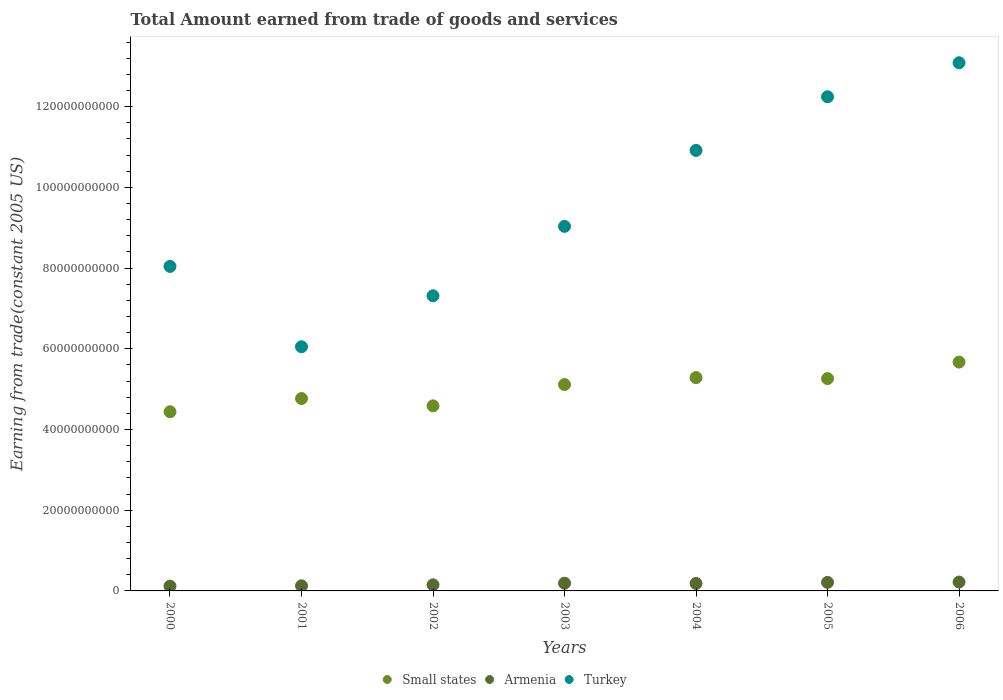Is the number of dotlines equal to the number of legend labels?
Make the answer very short. Yes. What is the total amount earned by trading goods and services in Small states in 2003?
Your answer should be very brief. 5.11e+1. Across all years, what is the maximum total amount earned by trading goods and services in Turkey?
Make the answer very short. 1.31e+11. Across all years, what is the minimum total amount earned by trading goods and services in Turkey?
Your response must be concise. 6.05e+1. In which year was the total amount earned by trading goods and services in Small states maximum?
Provide a short and direct response. 2006. What is the total total amount earned by trading goods and services in Turkey in the graph?
Ensure brevity in your answer.  6.67e+11. What is the difference between the total amount earned by trading goods and services in Armenia in 2001 and that in 2003?
Provide a succinct answer. -6.41e+08. What is the difference between the total amount earned by trading goods and services in Small states in 2006 and the total amount earned by trading goods and services in Armenia in 2002?
Your response must be concise. 5.52e+1. What is the average total amount earned by trading goods and services in Turkey per year?
Your answer should be compact. 9.53e+1. In the year 2003, what is the difference between the total amount earned by trading goods and services in Turkey and total amount earned by trading goods and services in Armenia?
Your answer should be compact. 8.84e+1. What is the ratio of the total amount earned by trading goods and services in Turkey in 2002 to that in 2005?
Give a very brief answer. 0.6. Is the total amount earned by trading goods and services in Turkey in 2003 less than that in 2006?
Your answer should be very brief. Yes. Is the difference between the total amount earned by trading goods and services in Turkey in 2002 and 2004 greater than the difference between the total amount earned by trading goods and services in Armenia in 2002 and 2004?
Ensure brevity in your answer.  No. What is the difference between the highest and the second highest total amount earned by trading goods and services in Turkey?
Provide a short and direct response. 8.43e+09. What is the difference between the highest and the lowest total amount earned by trading goods and services in Turkey?
Provide a short and direct response. 7.04e+1. In how many years, is the total amount earned by trading goods and services in Small states greater than the average total amount earned by trading goods and services in Small states taken over all years?
Provide a short and direct response. 4. Is the sum of the total amount earned by trading goods and services in Turkey in 2000 and 2003 greater than the maximum total amount earned by trading goods and services in Armenia across all years?
Offer a very short reply. Yes. Is it the case that in every year, the sum of the total amount earned by trading goods and services in Small states and total amount earned by trading goods and services in Armenia  is greater than the total amount earned by trading goods and services in Turkey?
Offer a very short reply. No. How many years are there in the graph?
Provide a short and direct response. 7. What is the difference between two consecutive major ticks on the Y-axis?
Give a very brief answer. 2.00e+1. Are the values on the major ticks of Y-axis written in scientific E-notation?
Provide a short and direct response. No. Where does the legend appear in the graph?
Give a very brief answer. Bottom center. How are the legend labels stacked?
Offer a very short reply. Horizontal. What is the title of the graph?
Offer a terse response. Total Amount earned from trade of goods and services. Does "Guam" appear as one of the legend labels in the graph?
Provide a succinct answer. No. What is the label or title of the X-axis?
Give a very brief answer. Years. What is the label or title of the Y-axis?
Keep it short and to the point. Earning from trade(constant 2005 US). What is the Earning from trade(constant 2005 US) in Small states in 2000?
Make the answer very short. 4.44e+1. What is the Earning from trade(constant 2005 US) of Armenia in 2000?
Provide a succinct answer. 1.19e+09. What is the Earning from trade(constant 2005 US) of Turkey in 2000?
Offer a terse response. 8.04e+1. What is the Earning from trade(constant 2005 US) in Small states in 2001?
Your answer should be very brief. 4.77e+1. What is the Earning from trade(constant 2005 US) in Armenia in 2001?
Give a very brief answer. 1.27e+09. What is the Earning from trade(constant 2005 US) of Turkey in 2001?
Provide a short and direct response. 6.05e+1. What is the Earning from trade(constant 2005 US) in Small states in 2002?
Offer a terse response. 4.59e+1. What is the Earning from trade(constant 2005 US) of Armenia in 2002?
Keep it short and to the point. 1.51e+09. What is the Earning from trade(constant 2005 US) of Turkey in 2002?
Your answer should be very brief. 7.31e+1. What is the Earning from trade(constant 2005 US) of Small states in 2003?
Your response must be concise. 5.11e+1. What is the Earning from trade(constant 2005 US) of Armenia in 2003?
Keep it short and to the point. 1.91e+09. What is the Earning from trade(constant 2005 US) of Turkey in 2003?
Your response must be concise. 9.03e+1. What is the Earning from trade(constant 2005 US) in Small states in 2004?
Provide a short and direct response. 5.29e+1. What is the Earning from trade(constant 2005 US) in Armenia in 2004?
Keep it short and to the point. 1.85e+09. What is the Earning from trade(constant 2005 US) in Turkey in 2004?
Offer a terse response. 1.09e+11. What is the Earning from trade(constant 2005 US) of Small states in 2005?
Provide a succinct answer. 5.26e+1. What is the Earning from trade(constant 2005 US) of Armenia in 2005?
Provide a succinct answer. 2.12e+09. What is the Earning from trade(constant 2005 US) in Turkey in 2005?
Provide a short and direct response. 1.22e+11. What is the Earning from trade(constant 2005 US) in Small states in 2006?
Your answer should be very brief. 5.67e+1. What is the Earning from trade(constant 2005 US) of Armenia in 2006?
Make the answer very short. 2.20e+09. What is the Earning from trade(constant 2005 US) in Turkey in 2006?
Make the answer very short. 1.31e+11. Across all years, what is the maximum Earning from trade(constant 2005 US) in Small states?
Your answer should be very brief. 5.67e+1. Across all years, what is the maximum Earning from trade(constant 2005 US) of Armenia?
Keep it short and to the point. 2.20e+09. Across all years, what is the maximum Earning from trade(constant 2005 US) of Turkey?
Your answer should be very brief. 1.31e+11. Across all years, what is the minimum Earning from trade(constant 2005 US) of Small states?
Provide a short and direct response. 4.44e+1. Across all years, what is the minimum Earning from trade(constant 2005 US) in Armenia?
Your response must be concise. 1.19e+09. Across all years, what is the minimum Earning from trade(constant 2005 US) in Turkey?
Your answer should be compact. 6.05e+1. What is the total Earning from trade(constant 2005 US) in Small states in the graph?
Offer a terse response. 3.51e+11. What is the total Earning from trade(constant 2005 US) in Armenia in the graph?
Keep it short and to the point. 1.20e+1. What is the total Earning from trade(constant 2005 US) in Turkey in the graph?
Your answer should be compact. 6.67e+11. What is the difference between the Earning from trade(constant 2005 US) of Small states in 2000 and that in 2001?
Offer a very short reply. -3.28e+09. What is the difference between the Earning from trade(constant 2005 US) of Armenia in 2000 and that in 2001?
Give a very brief answer. -7.64e+07. What is the difference between the Earning from trade(constant 2005 US) in Turkey in 2000 and that in 2001?
Keep it short and to the point. 1.99e+1. What is the difference between the Earning from trade(constant 2005 US) in Small states in 2000 and that in 2002?
Ensure brevity in your answer.  -1.47e+09. What is the difference between the Earning from trade(constant 2005 US) in Armenia in 2000 and that in 2002?
Offer a terse response. -3.17e+08. What is the difference between the Earning from trade(constant 2005 US) in Turkey in 2000 and that in 2002?
Offer a very short reply. 7.28e+09. What is the difference between the Earning from trade(constant 2005 US) in Small states in 2000 and that in 2003?
Make the answer very short. -6.75e+09. What is the difference between the Earning from trade(constant 2005 US) in Armenia in 2000 and that in 2003?
Your answer should be compact. -7.17e+08. What is the difference between the Earning from trade(constant 2005 US) of Turkey in 2000 and that in 2003?
Your response must be concise. -9.92e+09. What is the difference between the Earning from trade(constant 2005 US) in Small states in 2000 and that in 2004?
Keep it short and to the point. -8.46e+09. What is the difference between the Earning from trade(constant 2005 US) in Armenia in 2000 and that in 2004?
Provide a succinct answer. -6.61e+08. What is the difference between the Earning from trade(constant 2005 US) in Turkey in 2000 and that in 2004?
Make the answer very short. -2.87e+1. What is the difference between the Earning from trade(constant 2005 US) in Small states in 2000 and that in 2005?
Ensure brevity in your answer.  -8.22e+09. What is the difference between the Earning from trade(constant 2005 US) in Armenia in 2000 and that in 2005?
Your answer should be compact. -9.26e+08. What is the difference between the Earning from trade(constant 2005 US) of Turkey in 2000 and that in 2005?
Your response must be concise. -4.20e+1. What is the difference between the Earning from trade(constant 2005 US) in Small states in 2000 and that in 2006?
Keep it short and to the point. -1.23e+1. What is the difference between the Earning from trade(constant 2005 US) of Armenia in 2000 and that in 2006?
Offer a terse response. -1.01e+09. What is the difference between the Earning from trade(constant 2005 US) in Turkey in 2000 and that in 2006?
Your answer should be very brief. -5.05e+1. What is the difference between the Earning from trade(constant 2005 US) of Small states in 2001 and that in 2002?
Provide a succinct answer. 1.81e+09. What is the difference between the Earning from trade(constant 2005 US) in Armenia in 2001 and that in 2002?
Offer a very short reply. -2.40e+08. What is the difference between the Earning from trade(constant 2005 US) of Turkey in 2001 and that in 2002?
Keep it short and to the point. -1.26e+1. What is the difference between the Earning from trade(constant 2005 US) of Small states in 2001 and that in 2003?
Your response must be concise. -3.47e+09. What is the difference between the Earning from trade(constant 2005 US) of Armenia in 2001 and that in 2003?
Keep it short and to the point. -6.41e+08. What is the difference between the Earning from trade(constant 2005 US) of Turkey in 2001 and that in 2003?
Provide a short and direct response. -2.98e+1. What is the difference between the Earning from trade(constant 2005 US) of Small states in 2001 and that in 2004?
Make the answer very short. -5.18e+09. What is the difference between the Earning from trade(constant 2005 US) of Armenia in 2001 and that in 2004?
Give a very brief answer. -5.85e+08. What is the difference between the Earning from trade(constant 2005 US) of Turkey in 2001 and that in 2004?
Give a very brief answer. -4.87e+1. What is the difference between the Earning from trade(constant 2005 US) of Small states in 2001 and that in 2005?
Your answer should be compact. -4.94e+09. What is the difference between the Earning from trade(constant 2005 US) in Armenia in 2001 and that in 2005?
Your response must be concise. -8.50e+08. What is the difference between the Earning from trade(constant 2005 US) in Turkey in 2001 and that in 2005?
Offer a very short reply. -6.19e+1. What is the difference between the Earning from trade(constant 2005 US) in Small states in 2001 and that in 2006?
Ensure brevity in your answer.  -9.03e+09. What is the difference between the Earning from trade(constant 2005 US) of Armenia in 2001 and that in 2006?
Provide a short and direct response. -9.30e+08. What is the difference between the Earning from trade(constant 2005 US) in Turkey in 2001 and that in 2006?
Offer a very short reply. -7.04e+1. What is the difference between the Earning from trade(constant 2005 US) in Small states in 2002 and that in 2003?
Your response must be concise. -5.28e+09. What is the difference between the Earning from trade(constant 2005 US) of Armenia in 2002 and that in 2003?
Offer a terse response. -4.00e+08. What is the difference between the Earning from trade(constant 2005 US) in Turkey in 2002 and that in 2003?
Offer a very short reply. -1.72e+1. What is the difference between the Earning from trade(constant 2005 US) in Small states in 2002 and that in 2004?
Make the answer very short. -7.00e+09. What is the difference between the Earning from trade(constant 2005 US) in Armenia in 2002 and that in 2004?
Provide a succinct answer. -3.45e+08. What is the difference between the Earning from trade(constant 2005 US) of Turkey in 2002 and that in 2004?
Ensure brevity in your answer.  -3.60e+1. What is the difference between the Earning from trade(constant 2005 US) of Small states in 2002 and that in 2005?
Your response must be concise. -6.75e+09. What is the difference between the Earning from trade(constant 2005 US) of Armenia in 2002 and that in 2005?
Make the answer very short. -6.10e+08. What is the difference between the Earning from trade(constant 2005 US) of Turkey in 2002 and that in 2005?
Keep it short and to the point. -4.93e+1. What is the difference between the Earning from trade(constant 2005 US) in Small states in 2002 and that in 2006?
Ensure brevity in your answer.  -1.08e+1. What is the difference between the Earning from trade(constant 2005 US) in Armenia in 2002 and that in 2006?
Your answer should be very brief. -6.89e+08. What is the difference between the Earning from trade(constant 2005 US) in Turkey in 2002 and that in 2006?
Your response must be concise. -5.77e+1. What is the difference between the Earning from trade(constant 2005 US) in Small states in 2003 and that in 2004?
Provide a succinct answer. -1.72e+09. What is the difference between the Earning from trade(constant 2005 US) in Armenia in 2003 and that in 2004?
Your answer should be very brief. 5.58e+07. What is the difference between the Earning from trade(constant 2005 US) in Turkey in 2003 and that in 2004?
Your answer should be compact. -1.88e+1. What is the difference between the Earning from trade(constant 2005 US) in Small states in 2003 and that in 2005?
Provide a short and direct response. -1.47e+09. What is the difference between the Earning from trade(constant 2005 US) of Armenia in 2003 and that in 2005?
Your answer should be compact. -2.09e+08. What is the difference between the Earning from trade(constant 2005 US) of Turkey in 2003 and that in 2005?
Your answer should be very brief. -3.21e+1. What is the difference between the Earning from trade(constant 2005 US) of Small states in 2003 and that in 2006?
Ensure brevity in your answer.  -5.57e+09. What is the difference between the Earning from trade(constant 2005 US) in Armenia in 2003 and that in 2006?
Your answer should be very brief. -2.89e+08. What is the difference between the Earning from trade(constant 2005 US) of Turkey in 2003 and that in 2006?
Keep it short and to the point. -4.05e+1. What is the difference between the Earning from trade(constant 2005 US) of Small states in 2004 and that in 2005?
Offer a terse response. 2.44e+08. What is the difference between the Earning from trade(constant 2005 US) of Armenia in 2004 and that in 2005?
Keep it short and to the point. -2.65e+08. What is the difference between the Earning from trade(constant 2005 US) in Turkey in 2004 and that in 2005?
Provide a short and direct response. -1.33e+1. What is the difference between the Earning from trade(constant 2005 US) of Small states in 2004 and that in 2006?
Give a very brief answer. -3.85e+09. What is the difference between the Earning from trade(constant 2005 US) of Armenia in 2004 and that in 2006?
Your response must be concise. -3.45e+08. What is the difference between the Earning from trade(constant 2005 US) of Turkey in 2004 and that in 2006?
Give a very brief answer. -2.17e+1. What is the difference between the Earning from trade(constant 2005 US) in Small states in 2005 and that in 2006?
Give a very brief answer. -4.09e+09. What is the difference between the Earning from trade(constant 2005 US) in Armenia in 2005 and that in 2006?
Your answer should be compact. -7.97e+07. What is the difference between the Earning from trade(constant 2005 US) in Turkey in 2005 and that in 2006?
Ensure brevity in your answer.  -8.43e+09. What is the difference between the Earning from trade(constant 2005 US) of Small states in 2000 and the Earning from trade(constant 2005 US) of Armenia in 2001?
Ensure brevity in your answer.  4.31e+1. What is the difference between the Earning from trade(constant 2005 US) of Small states in 2000 and the Earning from trade(constant 2005 US) of Turkey in 2001?
Ensure brevity in your answer.  -1.61e+1. What is the difference between the Earning from trade(constant 2005 US) of Armenia in 2000 and the Earning from trade(constant 2005 US) of Turkey in 2001?
Offer a terse response. -5.93e+1. What is the difference between the Earning from trade(constant 2005 US) in Small states in 2000 and the Earning from trade(constant 2005 US) in Armenia in 2002?
Keep it short and to the point. 4.29e+1. What is the difference between the Earning from trade(constant 2005 US) in Small states in 2000 and the Earning from trade(constant 2005 US) in Turkey in 2002?
Your answer should be very brief. -2.87e+1. What is the difference between the Earning from trade(constant 2005 US) of Armenia in 2000 and the Earning from trade(constant 2005 US) of Turkey in 2002?
Keep it short and to the point. -7.19e+1. What is the difference between the Earning from trade(constant 2005 US) of Small states in 2000 and the Earning from trade(constant 2005 US) of Armenia in 2003?
Offer a very short reply. 4.25e+1. What is the difference between the Earning from trade(constant 2005 US) of Small states in 2000 and the Earning from trade(constant 2005 US) of Turkey in 2003?
Keep it short and to the point. -4.59e+1. What is the difference between the Earning from trade(constant 2005 US) in Armenia in 2000 and the Earning from trade(constant 2005 US) in Turkey in 2003?
Provide a short and direct response. -8.91e+1. What is the difference between the Earning from trade(constant 2005 US) in Small states in 2000 and the Earning from trade(constant 2005 US) in Armenia in 2004?
Your answer should be very brief. 4.25e+1. What is the difference between the Earning from trade(constant 2005 US) in Small states in 2000 and the Earning from trade(constant 2005 US) in Turkey in 2004?
Offer a very short reply. -6.48e+1. What is the difference between the Earning from trade(constant 2005 US) in Armenia in 2000 and the Earning from trade(constant 2005 US) in Turkey in 2004?
Ensure brevity in your answer.  -1.08e+11. What is the difference between the Earning from trade(constant 2005 US) of Small states in 2000 and the Earning from trade(constant 2005 US) of Armenia in 2005?
Provide a succinct answer. 4.23e+1. What is the difference between the Earning from trade(constant 2005 US) of Small states in 2000 and the Earning from trade(constant 2005 US) of Turkey in 2005?
Make the answer very short. -7.81e+1. What is the difference between the Earning from trade(constant 2005 US) in Armenia in 2000 and the Earning from trade(constant 2005 US) in Turkey in 2005?
Your answer should be compact. -1.21e+11. What is the difference between the Earning from trade(constant 2005 US) in Small states in 2000 and the Earning from trade(constant 2005 US) in Armenia in 2006?
Keep it short and to the point. 4.22e+1. What is the difference between the Earning from trade(constant 2005 US) in Small states in 2000 and the Earning from trade(constant 2005 US) in Turkey in 2006?
Provide a succinct answer. -8.65e+1. What is the difference between the Earning from trade(constant 2005 US) of Armenia in 2000 and the Earning from trade(constant 2005 US) of Turkey in 2006?
Offer a terse response. -1.30e+11. What is the difference between the Earning from trade(constant 2005 US) of Small states in 2001 and the Earning from trade(constant 2005 US) of Armenia in 2002?
Your response must be concise. 4.62e+1. What is the difference between the Earning from trade(constant 2005 US) of Small states in 2001 and the Earning from trade(constant 2005 US) of Turkey in 2002?
Offer a terse response. -2.55e+1. What is the difference between the Earning from trade(constant 2005 US) in Armenia in 2001 and the Earning from trade(constant 2005 US) in Turkey in 2002?
Your answer should be very brief. -7.19e+1. What is the difference between the Earning from trade(constant 2005 US) in Small states in 2001 and the Earning from trade(constant 2005 US) in Armenia in 2003?
Provide a short and direct response. 4.58e+1. What is the difference between the Earning from trade(constant 2005 US) of Small states in 2001 and the Earning from trade(constant 2005 US) of Turkey in 2003?
Keep it short and to the point. -4.27e+1. What is the difference between the Earning from trade(constant 2005 US) in Armenia in 2001 and the Earning from trade(constant 2005 US) in Turkey in 2003?
Offer a terse response. -8.91e+1. What is the difference between the Earning from trade(constant 2005 US) in Small states in 2001 and the Earning from trade(constant 2005 US) in Armenia in 2004?
Your answer should be compact. 4.58e+1. What is the difference between the Earning from trade(constant 2005 US) of Small states in 2001 and the Earning from trade(constant 2005 US) of Turkey in 2004?
Offer a terse response. -6.15e+1. What is the difference between the Earning from trade(constant 2005 US) in Armenia in 2001 and the Earning from trade(constant 2005 US) in Turkey in 2004?
Your response must be concise. -1.08e+11. What is the difference between the Earning from trade(constant 2005 US) of Small states in 2001 and the Earning from trade(constant 2005 US) of Armenia in 2005?
Your response must be concise. 4.56e+1. What is the difference between the Earning from trade(constant 2005 US) of Small states in 2001 and the Earning from trade(constant 2005 US) of Turkey in 2005?
Your response must be concise. -7.48e+1. What is the difference between the Earning from trade(constant 2005 US) in Armenia in 2001 and the Earning from trade(constant 2005 US) in Turkey in 2005?
Offer a very short reply. -1.21e+11. What is the difference between the Earning from trade(constant 2005 US) in Small states in 2001 and the Earning from trade(constant 2005 US) in Armenia in 2006?
Provide a short and direct response. 4.55e+1. What is the difference between the Earning from trade(constant 2005 US) in Small states in 2001 and the Earning from trade(constant 2005 US) in Turkey in 2006?
Ensure brevity in your answer.  -8.32e+1. What is the difference between the Earning from trade(constant 2005 US) in Armenia in 2001 and the Earning from trade(constant 2005 US) in Turkey in 2006?
Give a very brief answer. -1.30e+11. What is the difference between the Earning from trade(constant 2005 US) of Small states in 2002 and the Earning from trade(constant 2005 US) of Armenia in 2003?
Offer a very short reply. 4.39e+1. What is the difference between the Earning from trade(constant 2005 US) of Small states in 2002 and the Earning from trade(constant 2005 US) of Turkey in 2003?
Offer a terse response. -4.45e+1. What is the difference between the Earning from trade(constant 2005 US) of Armenia in 2002 and the Earning from trade(constant 2005 US) of Turkey in 2003?
Give a very brief answer. -8.88e+1. What is the difference between the Earning from trade(constant 2005 US) of Small states in 2002 and the Earning from trade(constant 2005 US) of Armenia in 2004?
Ensure brevity in your answer.  4.40e+1. What is the difference between the Earning from trade(constant 2005 US) in Small states in 2002 and the Earning from trade(constant 2005 US) in Turkey in 2004?
Keep it short and to the point. -6.33e+1. What is the difference between the Earning from trade(constant 2005 US) in Armenia in 2002 and the Earning from trade(constant 2005 US) in Turkey in 2004?
Your response must be concise. -1.08e+11. What is the difference between the Earning from trade(constant 2005 US) of Small states in 2002 and the Earning from trade(constant 2005 US) of Armenia in 2005?
Give a very brief answer. 4.37e+1. What is the difference between the Earning from trade(constant 2005 US) in Small states in 2002 and the Earning from trade(constant 2005 US) in Turkey in 2005?
Make the answer very short. -7.66e+1. What is the difference between the Earning from trade(constant 2005 US) of Armenia in 2002 and the Earning from trade(constant 2005 US) of Turkey in 2005?
Give a very brief answer. -1.21e+11. What is the difference between the Earning from trade(constant 2005 US) in Small states in 2002 and the Earning from trade(constant 2005 US) in Armenia in 2006?
Give a very brief answer. 4.37e+1. What is the difference between the Earning from trade(constant 2005 US) in Small states in 2002 and the Earning from trade(constant 2005 US) in Turkey in 2006?
Make the answer very short. -8.50e+1. What is the difference between the Earning from trade(constant 2005 US) of Armenia in 2002 and the Earning from trade(constant 2005 US) of Turkey in 2006?
Keep it short and to the point. -1.29e+11. What is the difference between the Earning from trade(constant 2005 US) in Small states in 2003 and the Earning from trade(constant 2005 US) in Armenia in 2004?
Your answer should be compact. 4.93e+1. What is the difference between the Earning from trade(constant 2005 US) of Small states in 2003 and the Earning from trade(constant 2005 US) of Turkey in 2004?
Provide a short and direct response. -5.80e+1. What is the difference between the Earning from trade(constant 2005 US) in Armenia in 2003 and the Earning from trade(constant 2005 US) in Turkey in 2004?
Your response must be concise. -1.07e+11. What is the difference between the Earning from trade(constant 2005 US) of Small states in 2003 and the Earning from trade(constant 2005 US) of Armenia in 2005?
Make the answer very short. 4.90e+1. What is the difference between the Earning from trade(constant 2005 US) of Small states in 2003 and the Earning from trade(constant 2005 US) of Turkey in 2005?
Your answer should be compact. -7.13e+1. What is the difference between the Earning from trade(constant 2005 US) in Armenia in 2003 and the Earning from trade(constant 2005 US) in Turkey in 2005?
Ensure brevity in your answer.  -1.21e+11. What is the difference between the Earning from trade(constant 2005 US) in Small states in 2003 and the Earning from trade(constant 2005 US) in Armenia in 2006?
Make the answer very short. 4.89e+1. What is the difference between the Earning from trade(constant 2005 US) in Small states in 2003 and the Earning from trade(constant 2005 US) in Turkey in 2006?
Your answer should be compact. -7.97e+1. What is the difference between the Earning from trade(constant 2005 US) of Armenia in 2003 and the Earning from trade(constant 2005 US) of Turkey in 2006?
Give a very brief answer. -1.29e+11. What is the difference between the Earning from trade(constant 2005 US) of Small states in 2004 and the Earning from trade(constant 2005 US) of Armenia in 2005?
Offer a terse response. 5.07e+1. What is the difference between the Earning from trade(constant 2005 US) in Small states in 2004 and the Earning from trade(constant 2005 US) in Turkey in 2005?
Your answer should be very brief. -6.96e+1. What is the difference between the Earning from trade(constant 2005 US) of Armenia in 2004 and the Earning from trade(constant 2005 US) of Turkey in 2005?
Ensure brevity in your answer.  -1.21e+11. What is the difference between the Earning from trade(constant 2005 US) of Small states in 2004 and the Earning from trade(constant 2005 US) of Armenia in 2006?
Provide a succinct answer. 5.07e+1. What is the difference between the Earning from trade(constant 2005 US) in Small states in 2004 and the Earning from trade(constant 2005 US) in Turkey in 2006?
Provide a short and direct response. -7.80e+1. What is the difference between the Earning from trade(constant 2005 US) in Armenia in 2004 and the Earning from trade(constant 2005 US) in Turkey in 2006?
Offer a terse response. -1.29e+11. What is the difference between the Earning from trade(constant 2005 US) of Small states in 2005 and the Earning from trade(constant 2005 US) of Armenia in 2006?
Provide a short and direct response. 5.04e+1. What is the difference between the Earning from trade(constant 2005 US) in Small states in 2005 and the Earning from trade(constant 2005 US) in Turkey in 2006?
Give a very brief answer. -7.83e+1. What is the difference between the Earning from trade(constant 2005 US) in Armenia in 2005 and the Earning from trade(constant 2005 US) in Turkey in 2006?
Give a very brief answer. -1.29e+11. What is the average Earning from trade(constant 2005 US) of Small states per year?
Your answer should be very brief. 5.02e+1. What is the average Earning from trade(constant 2005 US) in Armenia per year?
Offer a very short reply. 1.72e+09. What is the average Earning from trade(constant 2005 US) in Turkey per year?
Offer a terse response. 9.53e+1. In the year 2000, what is the difference between the Earning from trade(constant 2005 US) in Small states and Earning from trade(constant 2005 US) in Armenia?
Your answer should be compact. 4.32e+1. In the year 2000, what is the difference between the Earning from trade(constant 2005 US) of Small states and Earning from trade(constant 2005 US) of Turkey?
Keep it short and to the point. -3.60e+1. In the year 2000, what is the difference between the Earning from trade(constant 2005 US) of Armenia and Earning from trade(constant 2005 US) of Turkey?
Make the answer very short. -7.92e+1. In the year 2001, what is the difference between the Earning from trade(constant 2005 US) in Small states and Earning from trade(constant 2005 US) in Armenia?
Keep it short and to the point. 4.64e+1. In the year 2001, what is the difference between the Earning from trade(constant 2005 US) of Small states and Earning from trade(constant 2005 US) of Turkey?
Provide a short and direct response. -1.28e+1. In the year 2001, what is the difference between the Earning from trade(constant 2005 US) of Armenia and Earning from trade(constant 2005 US) of Turkey?
Offer a terse response. -5.92e+1. In the year 2002, what is the difference between the Earning from trade(constant 2005 US) of Small states and Earning from trade(constant 2005 US) of Armenia?
Provide a short and direct response. 4.43e+1. In the year 2002, what is the difference between the Earning from trade(constant 2005 US) in Small states and Earning from trade(constant 2005 US) in Turkey?
Provide a short and direct response. -2.73e+1. In the year 2002, what is the difference between the Earning from trade(constant 2005 US) of Armenia and Earning from trade(constant 2005 US) of Turkey?
Your response must be concise. -7.16e+1. In the year 2003, what is the difference between the Earning from trade(constant 2005 US) in Small states and Earning from trade(constant 2005 US) in Armenia?
Keep it short and to the point. 4.92e+1. In the year 2003, what is the difference between the Earning from trade(constant 2005 US) in Small states and Earning from trade(constant 2005 US) in Turkey?
Provide a short and direct response. -3.92e+1. In the year 2003, what is the difference between the Earning from trade(constant 2005 US) in Armenia and Earning from trade(constant 2005 US) in Turkey?
Your answer should be very brief. -8.84e+1. In the year 2004, what is the difference between the Earning from trade(constant 2005 US) of Small states and Earning from trade(constant 2005 US) of Armenia?
Ensure brevity in your answer.  5.10e+1. In the year 2004, what is the difference between the Earning from trade(constant 2005 US) in Small states and Earning from trade(constant 2005 US) in Turkey?
Ensure brevity in your answer.  -5.63e+1. In the year 2004, what is the difference between the Earning from trade(constant 2005 US) in Armenia and Earning from trade(constant 2005 US) in Turkey?
Give a very brief answer. -1.07e+11. In the year 2005, what is the difference between the Earning from trade(constant 2005 US) in Small states and Earning from trade(constant 2005 US) in Armenia?
Your answer should be very brief. 5.05e+1. In the year 2005, what is the difference between the Earning from trade(constant 2005 US) of Small states and Earning from trade(constant 2005 US) of Turkey?
Your answer should be very brief. -6.98e+1. In the year 2005, what is the difference between the Earning from trade(constant 2005 US) in Armenia and Earning from trade(constant 2005 US) in Turkey?
Keep it short and to the point. -1.20e+11. In the year 2006, what is the difference between the Earning from trade(constant 2005 US) of Small states and Earning from trade(constant 2005 US) of Armenia?
Provide a succinct answer. 5.45e+1. In the year 2006, what is the difference between the Earning from trade(constant 2005 US) in Small states and Earning from trade(constant 2005 US) in Turkey?
Ensure brevity in your answer.  -7.42e+1. In the year 2006, what is the difference between the Earning from trade(constant 2005 US) in Armenia and Earning from trade(constant 2005 US) in Turkey?
Make the answer very short. -1.29e+11. What is the ratio of the Earning from trade(constant 2005 US) of Small states in 2000 to that in 2001?
Give a very brief answer. 0.93. What is the ratio of the Earning from trade(constant 2005 US) of Armenia in 2000 to that in 2001?
Your answer should be compact. 0.94. What is the ratio of the Earning from trade(constant 2005 US) in Turkey in 2000 to that in 2001?
Provide a succinct answer. 1.33. What is the ratio of the Earning from trade(constant 2005 US) of Armenia in 2000 to that in 2002?
Give a very brief answer. 0.79. What is the ratio of the Earning from trade(constant 2005 US) in Turkey in 2000 to that in 2002?
Offer a terse response. 1.1. What is the ratio of the Earning from trade(constant 2005 US) in Small states in 2000 to that in 2003?
Ensure brevity in your answer.  0.87. What is the ratio of the Earning from trade(constant 2005 US) of Armenia in 2000 to that in 2003?
Offer a very short reply. 0.62. What is the ratio of the Earning from trade(constant 2005 US) of Turkey in 2000 to that in 2003?
Offer a very short reply. 0.89. What is the ratio of the Earning from trade(constant 2005 US) in Small states in 2000 to that in 2004?
Your response must be concise. 0.84. What is the ratio of the Earning from trade(constant 2005 US) in Armenia in 2000 to that in 2004?
Keep it short and to the point. 0.64. What is the ratio of the Earning from trade(constant 2005 US) in Turkey in 2000 to that in 2004?
Offer a terse response. 0.74. What is the ratio of the Earning from trade(constant 2005 US) in Small states in 2000 to that in 2005?
Keep it short and to the point. 0.84. What is the ratio of the Earning from trade(constant 2005 US) in Armenia in 2000 to that in 2005?
Ensure brevity in your answer.  0.56. What is the ratio of the Earning from trade(constant 2005 US) in Turkey in 2000 to that in 2005?
Ensure brevity in your answer.  0.66. What is the ratio of the Earning from trade(constant 2005 US) of Small states in 2000 to that in 2006?
Your answer should be very brief. 0.78. What is the ratio of the Earning from trade(constant 2005 US) of Armenia in 2000 to that in 2006?
Your answer should be very brief. 0.54. What is the ratio of the Earning from trade(constant 2005 US) in Turkey in 2000 to that in 2006?
Make the answer very short. 0.61. What is the ratio of the Earning from trade(constant 2005 US) of Small states in 2001 to that in 2002?
Provide a short and direct response. 1.04. What is the ratio of the Earning from trade(constant 2005 US) of Armenia in 2001 to that in 2002?
Offer a very short reply. 0.84. What is the ratio of the Earning from trade(constant 2005 US) of Turkey in 2001 to that in 2002?
Your answer should be very brief. 0.83. What is the ratio of the Earning from trade(constant 2005 US) in Small states in 2001 to that in 2003?
Provide a succinct answer. 0.93. What is the ratio of the Earning from trade(constant 2005 US) in Armenia in 2001 to that in 2003?
Ensure brevity in your answer.  0.66. What is the ratio of the Earning from trade(constant 2005 US) of Turkey in 2001 to that in 2003?
Ensure brevity in your answer.  0.67. What is the ratio of the Earning from trade(constant 2005 US) in Small states in 2001 to that in 2004?
Give a very brief answer. 0.9. What is the ratio of the Earning from trade(constant 2005 US) in Armenia in 2001 to that in 2004?
Provide a succinct answer. 0.68. What is the ratio of the Earning from trade(constant 2005 US) in Turkey in 2001 to that in 2004?
Your response must be concise. 0.55. What is the ratio of the Earning from trade(constant 2005 US) in Small states in 2001 to that in 2005?
Keep it short and to the point. 0.91. What is the ratio of the Earning from trade(constant 2005 US) in Armenia in 2001 to that in 2005?
Give a very brief answer. 0.6. What is the ratio of the Earning from trade(constant 2005 US) in Turkey in 2001 to that in 2005?
Offer a very short reply. 0.49. What is the ratio of the Earning from trade(constant 2005 US) of Small states in 2001 to that in 2006?
Provide a short and direct response. 0.84. What is the ratio of the Earning from trade(constant 2005 US) in Armenia in 2001 to that in 2006?
Your response must be concise. 0.58. What is the ratio of the Earning from trade(constant 2005 US) in Turkey in 2001 to that in 2006?
Your answer should be compact. 0.46. What is the ratio of the Earning from trade(constant 2005 US) in Small states in 2002 to that in 2003?
Provide a short and direct response. 0.9. What is the ratio of the Earning from trade(constant 2005 US) of Armenia in 2002 to that in 2003?
Keep it short and to the point. 0.79. What is the ratio of the Earning from trade(constant 2005 US) in Turkey in 2002 to that in 2003?
Make the answer very short. 0.81. What is the ratio of the Earning from trade(constant 2005 US) in Small states in 2002 to that in 2004?
Provide a succinct answer. 0.87. What is the ratio of the Earning from trade(constant 2005 US) in Armenia in 2002 to that in 2004?
Make the answer very short. 0.81. What is the ratio of the Earning from trade(constant 2005 US) in Turkey in 2002 to that in 2004?
Offer a terse response. 0.67. What is the ratio of the Earning from trade(constant 2005 US) of Small states in 2002 to that in 2005?
Give a very brief answer. 0.87. What is the ratio of the Earning from trade(constant 2005 US) of Armenia in 2002 to that in 2005?
Ensure brevity in your answer.  0.71. What is the ratio of the Earning from trade(constant 2005 US) of Turkey in 2002 to that in 2005?
Keep it short and to the point. 0.6. What is the ratio of the Earning from trade(constant 2005 US) of Small states in 2002 to that in 2006?
Your answer should be compact. 0.81. What is the ratio of the Earning from trade(constant 2005 US) of Armenia in 2002 to that in 2006?
Offer a terse response. 0.69. What is the ratio of the Earning from trade(constant 2005 US) in Turkey in 2002 to that in 2006?
Keep it short and to the point. 0.56. What is the ratio of the Earning from trade(constant 2005 US) in Small states in 2003 to that in 2004?
Ensure brevity in your answer.  0.97. What is the ratio of the Earning from trade(constant 2005 US) of Armenia in 2003 to that in 2004?
Your answer should be compact. 1.03. What is the ratio of the Earning from trade(constant 2005 US) of Turkey in 2003 to that in 2004?
Your response must be concise. 0.83. What is the ratio of the Earning from trade(constant 2005 US) in Armenia in 2003 to that in 2005?
Offer a terse response. 0.9. What is the ratio of the Earning from trade(constant 2005 US) of Turkey in 2003 to that in 2005?
Keep it short and to the point. 0.74. What is the ratio of the Earning from trade(constant 2005 US) in Small states in 2003 to that in 2006?
Your response must be concise. 0.9. What is the ratio of the Earning from trade(constant 2005 US) of Armenia in 2003 to that in 2006?
Your response must be concise. 0.87. What is the ratio of the Earning from trade(constant 2005 US) of Turkey in 2003 to that in 2006?
Give a very brief answer. 0.69. What is the ratio of the Earning from trade(constant 2005 US) of Armenia in 2004 to that in 2005?
Ensure brevity in your answer.  0.87. What is the ratio of the Earning from trade(constant 2005 US) in Turkey in 2004 to that in 2005?
Provide a succinct answer. 0.89. What is the ratio of the Earning from trade(constant 2005 US) of Small states in 2004 to that in 2006?
Your answer should be very brief. 0.93. What is the ratio of the Earning from trade(constant 2005 US) of Armenia in 2004 to that in 2006?
Keep it short and to the point. 0.84. What is the ratio of the Earning from trade(constant 2005 US) in Turkey in 2004 to that in 2006?
Offer a terse response. 0.83. What is the ratio of the Earning from trade(constant 2005 US) of Small states in 2005 to that in 2006?
Provide a succinct answer. 0.93. What is the ratio of the Earning from trade(constant 2005 US) of Armenia in 2005 to that in 2006?
Offer a very short reply. 0.96. What is the ratio of the Earning from trade(constant 2005 US) in Turkey in 2005 to that in 2006?
Make the answer very short. 0.94. What is the difference between the highest and the second highest Earning from trade(constant 2005 US) of Small states?
Make the answer very short. 3.85e+09. What is the difference between the highest and the second highest Earning from trade(constant 2005 US) of Armenia?
Offer a terse response. 7.97e+07. What is the difference between the highest and the second highest Earning from trade(constant 2005 US) of Turkey?
Keep it short and to the point. 8.43e+09. What is the difference between the highest and the lowest Earning from trade(constant 2005 US) in Small states?
Your response must be concise. 1.23e+1. What is the difference between the highest and the lowest Earning from trade(constant 2005 US) in Armenia?
Make the answer very short. 1.01e+09. What is the difference between the highest and the lowest Earning from trade(constant 2005 US) of Turkey?
Give a very brief answer. 7.04e+1. 